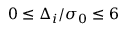<formula> <loc_0><loc_0><loc_500><loc_500>0 \leq \Delta _ { i } / \sigma _ { 0 } \leq 6</formula> 